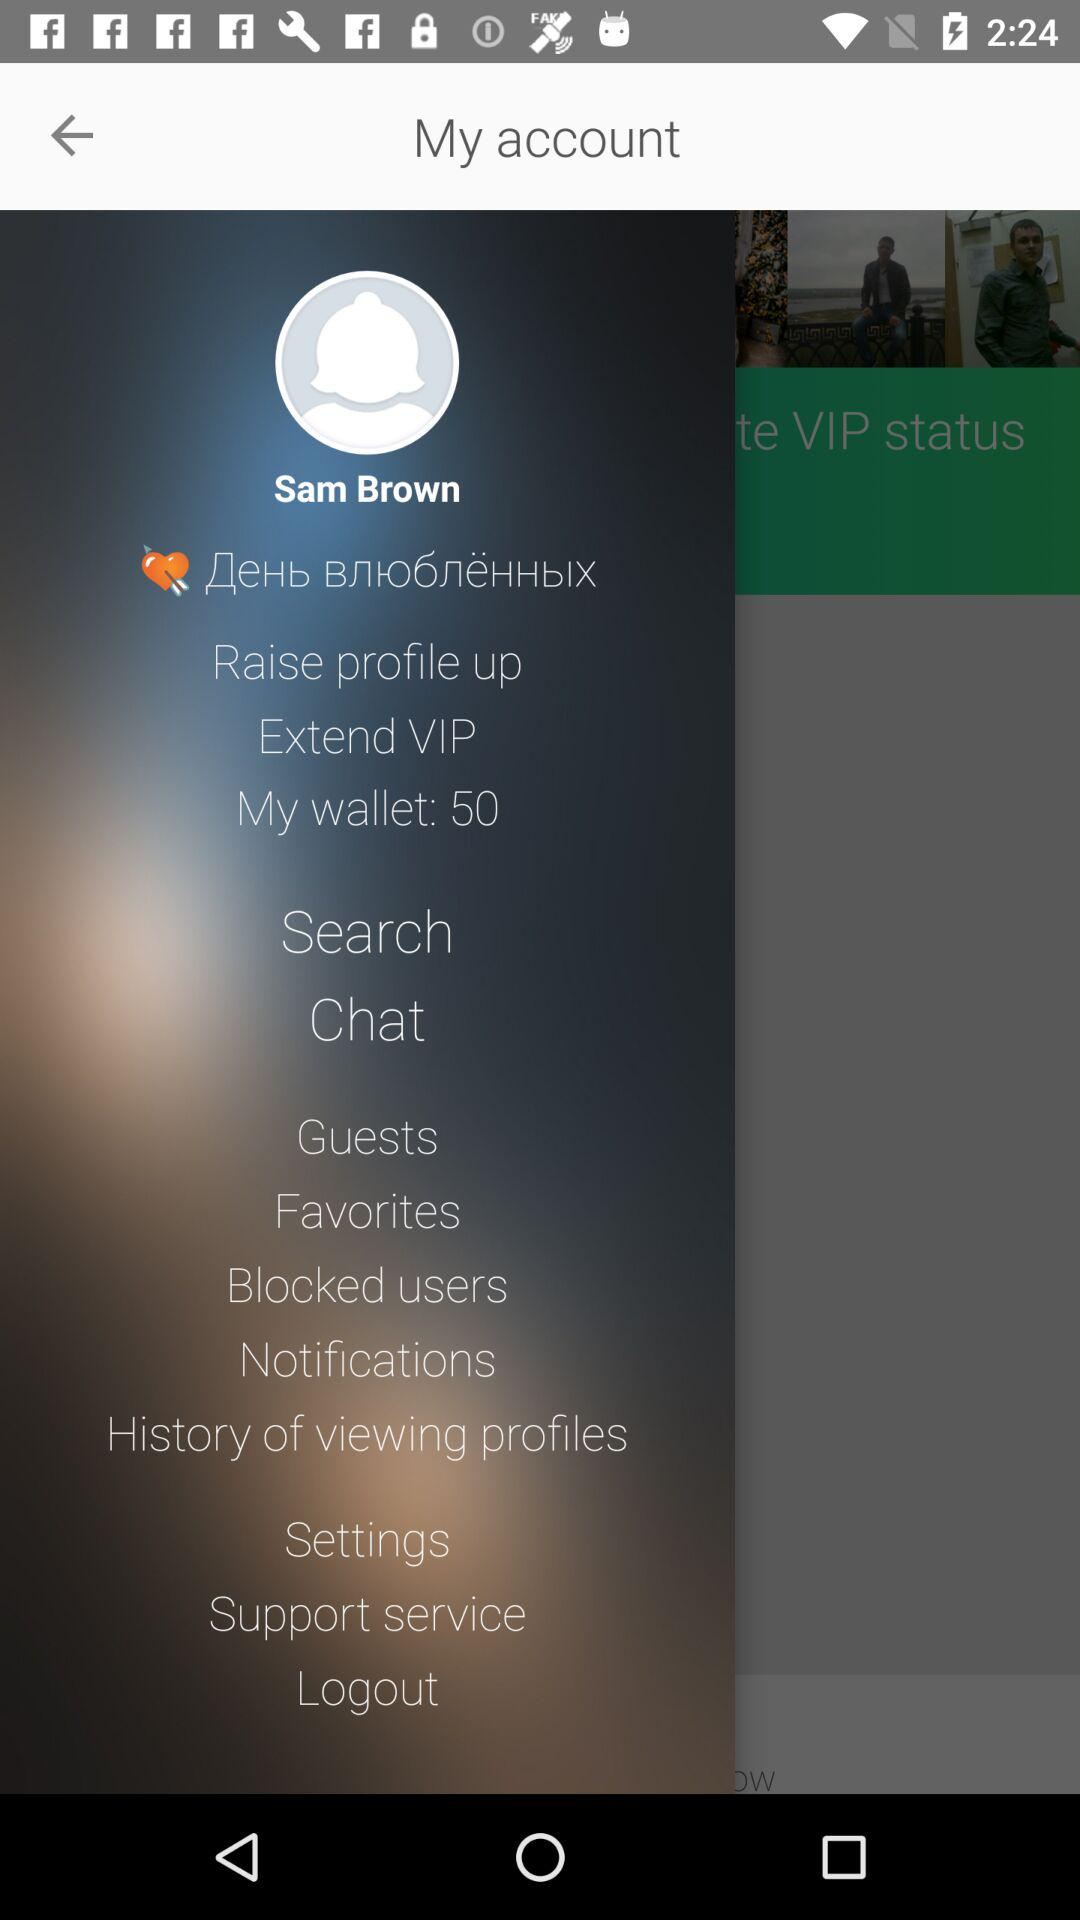What is the username? The username is Sam Brown. 